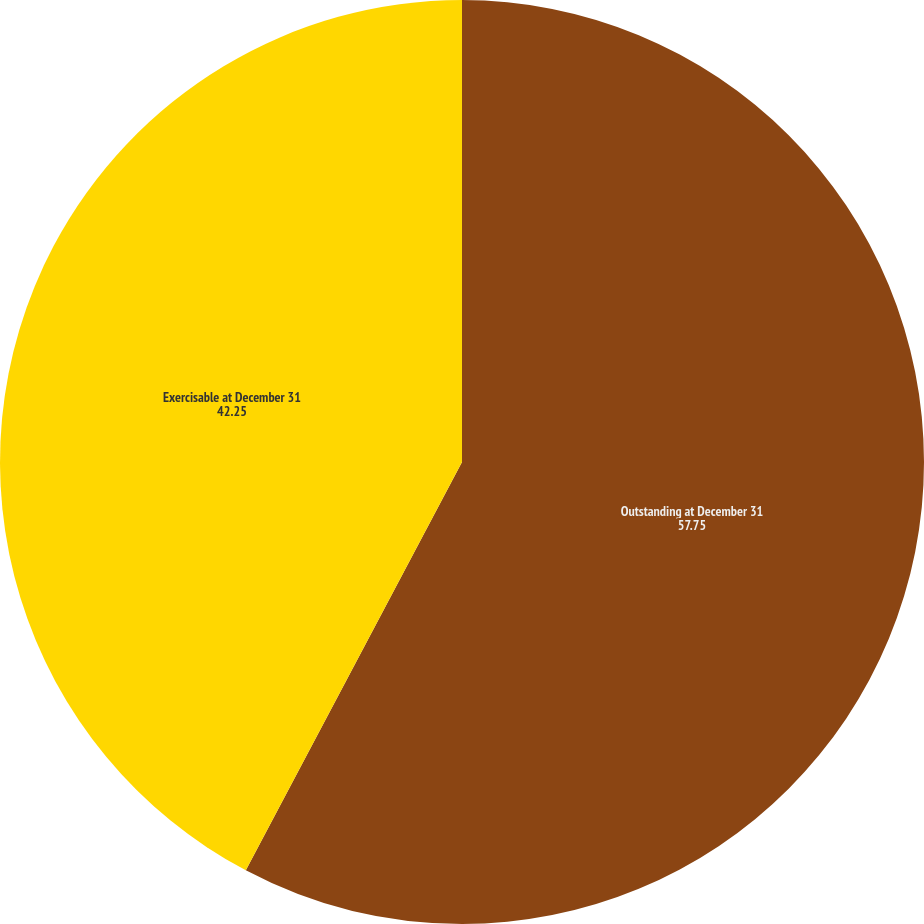<chart> <loc_0><loc_0><loc_500><loc_500><pie_chart><fcel>Outstanding at December 31<fcel>Exercisable at December 31<nl><fcel>57.75%<fcel>42.25%<nl></chart> 